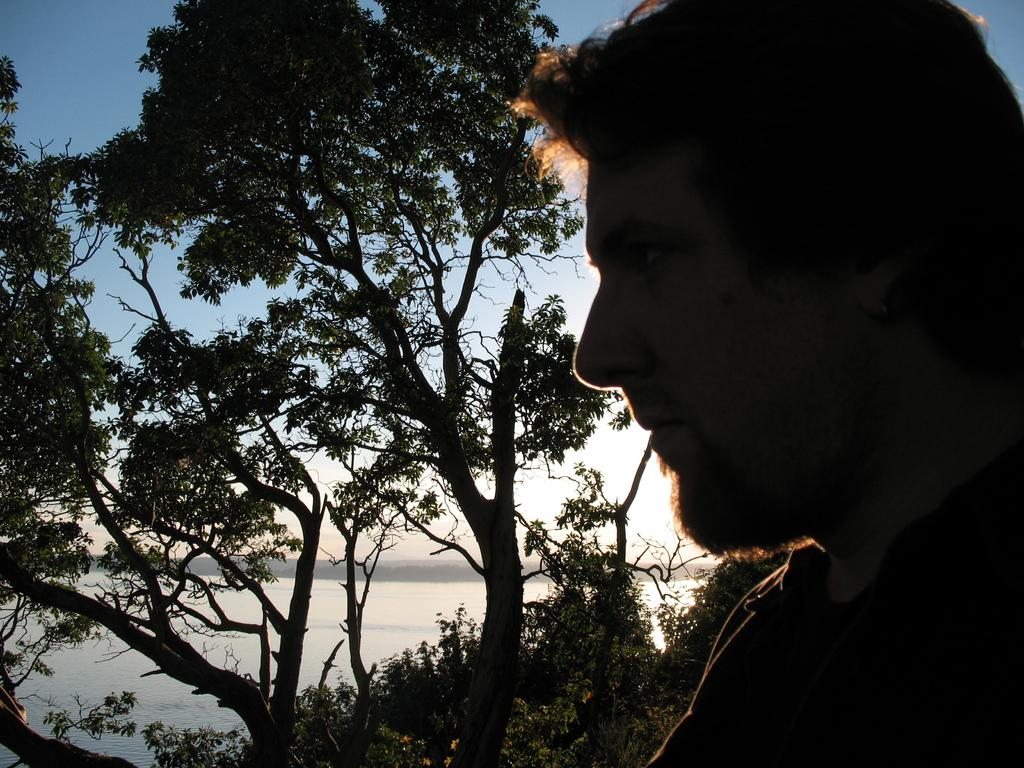Who or what is present in the image? There is a person in the image. What is located behind the person? There are trees behind the person. What natural element can be seen in the image? Water is visible in the image. What is visible at the top of the image? The sky is visible at the top of the image. What type of music is the person playing in the image? There is no indication of music or any musical instrument in the image. 